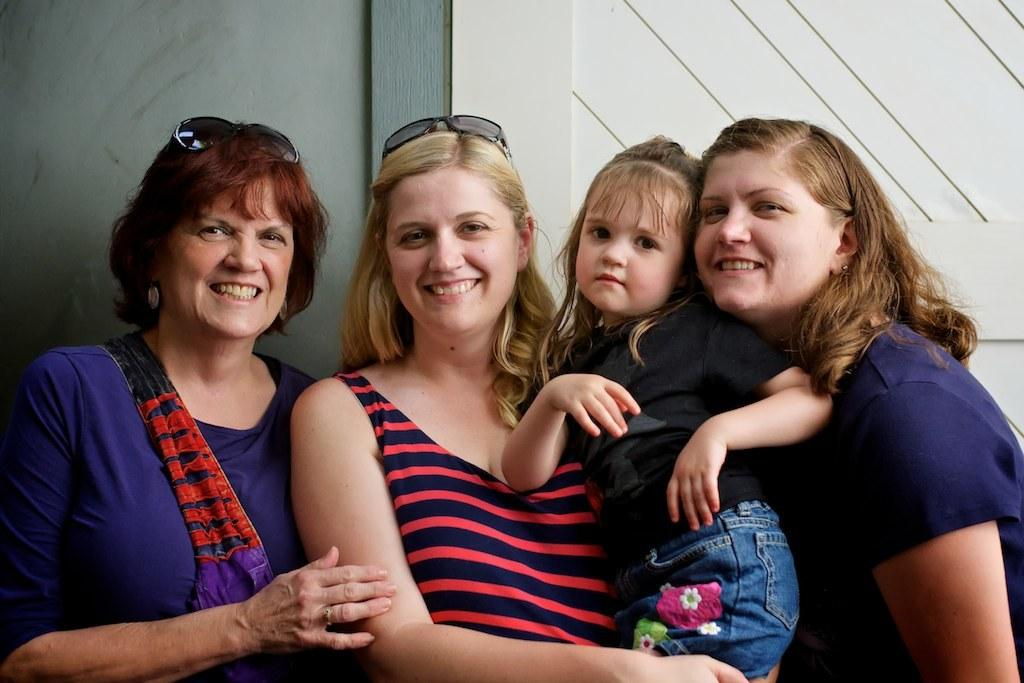How many women are in the image? There are three women standing and smiling in the image. What is one of the women doing with a child? One of the women is carrying a girl in her hands. What can be seen in the background of the image? There is a door and a wall visible in the background of the image. What type of blood is visible on the train in the image? There is no train or blood present in the image. Is there a party happening in the image? There is no indication of a party in the image. 